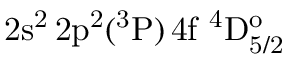Convert formula to latex. <formula><loc_0><loc_0><loc_500><loc_500>2 s ^ { 2 } \, 2 p ^ { 2 } ( ^ { 3 } P ) \, 4 f ^ { 4 } D _ { 5 / 2 } ^ { o }</formula> 